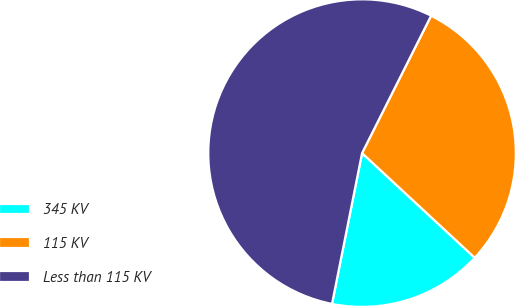Convert chart. <chart><loc_0><loc_0><loc_500><loc_500><pie_chart><fcel>345 KV<fcel>115 KV<fcel>Less than 115 KV<nl><fcel>16.22%<fcel>29.5%<fcel>54.28%<nl></chart> 